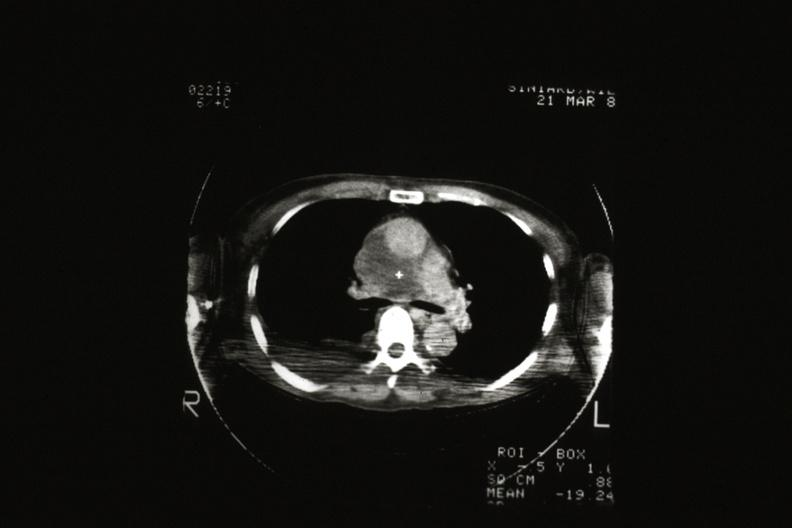does this image show cat scan showing tumor invading superior vena ca?
Answer the question using a single word or phrase. Yes 